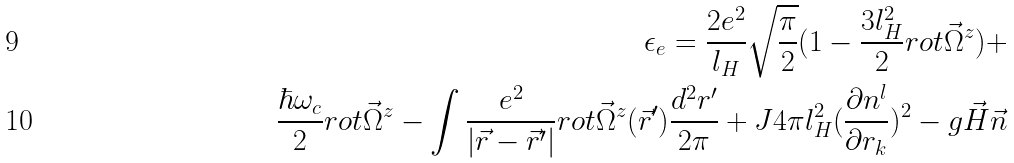<formula> <loc_0><loc_0><loc_500><loc_500>\epsilon _ { e } = \frac { 2 e ^ { 2 } } { l _ { H } } \sqrt { \frac { \pi } { 2 } } ( 1 - \frac { 3 l _ { H } ^ { 2 } } { 2 } r o t \vec { \Omega } ^ { z } ) + \\ \frac { \hbar { \omega } _ { c } } { 2 } r o t \vec { \Omega } ^ { z } - \int \frac { e ^ { 2 } } { | \vec { r } - \vec { r } ^ { \prime } | } r o t \vec { \Omega } ^ { z } ( \vec { r } ^ { \prime } ) \frac { d ^ { 2 } r ^ { \prime } } { 2 \pi } + J 4 \pi l _ { H } ^ { 2 } ( \frac { \partial { n ^ { l } } } { \partial { r _ { k } } } ) ^ { 2 } - g \vec { H } \vec { n }</formula> 